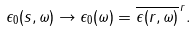<formula> <loc_0><loc_0><loc_500><loc_500>\epsilon _ { 0 } ( { s } , \omega ) \to \epsilon _ { 0 } ( \omega ) = \overline { \epsilon ( { r } , \omega ) } ^ { \, { r } } .</formula> 